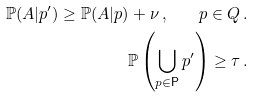Convert formula to latex. <formula><loc_0><loc_0><loc_500><loc_500>\mathbb { P } ( A | p ^ { \prime } ) \geq \mathbb { P } ( A | p ) + \nu \, , \quad p \in Q \, . \\ \mathbb { P } \left ( \bigcup _ { p \in \mathsf P } p ^ { \prime } \right ) \geq \tau \, .</formula> 